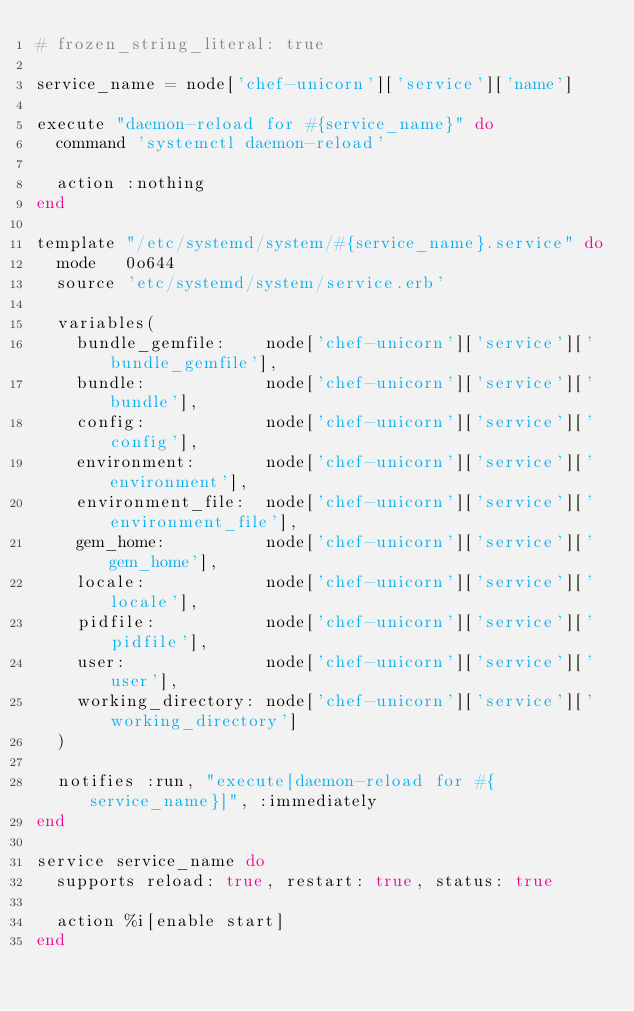Convert code to text. <code><loc_0><loc_0><loc_500><loc_500><_Ruby_># frozen_string_literal: true

service_name = node['chef-unicorn']['service']['name']

execute "daemon-reload for #{service_name}" do
  command 'systemctl daemon-reload'

  action :nothing
end

template "/etc/systemd/system/#{service_name}.service" do
  mode   0o644
  source 'etc/systemd/system/service.erb'

  variables(
    bundle_gemfile:    node['chef-unicorn']['service']['bundle_gemfile'],
    bundle:            node['chef-unicorn']['service']['bundle'],
    config:            node['chef-unicorn']['service']['config'],
    environment:       node['chef-unicorn']['service']['environment'],
    environment_file:  node['chef-unicorn']['service']['environment_file'],
    gem_home:          node['chef-unicorn']['service']['gem_home'],
    locale:            node['chef-unicorn']['service']['locale'],
    pidfile:           node['chef-unicorn']['service']['pidfile'],
    user:              node['chef-unicorn']['service']['user'],
    working_directory: node['chef-unicorn']['service']['working_directory']
  )

  notifies :run, "execute[daemon-reload for #{service_name}]", :immediately
end

service service_name do
  supports reload: true, restart: true, status: true

  action %i[enable start]
end
</code> 